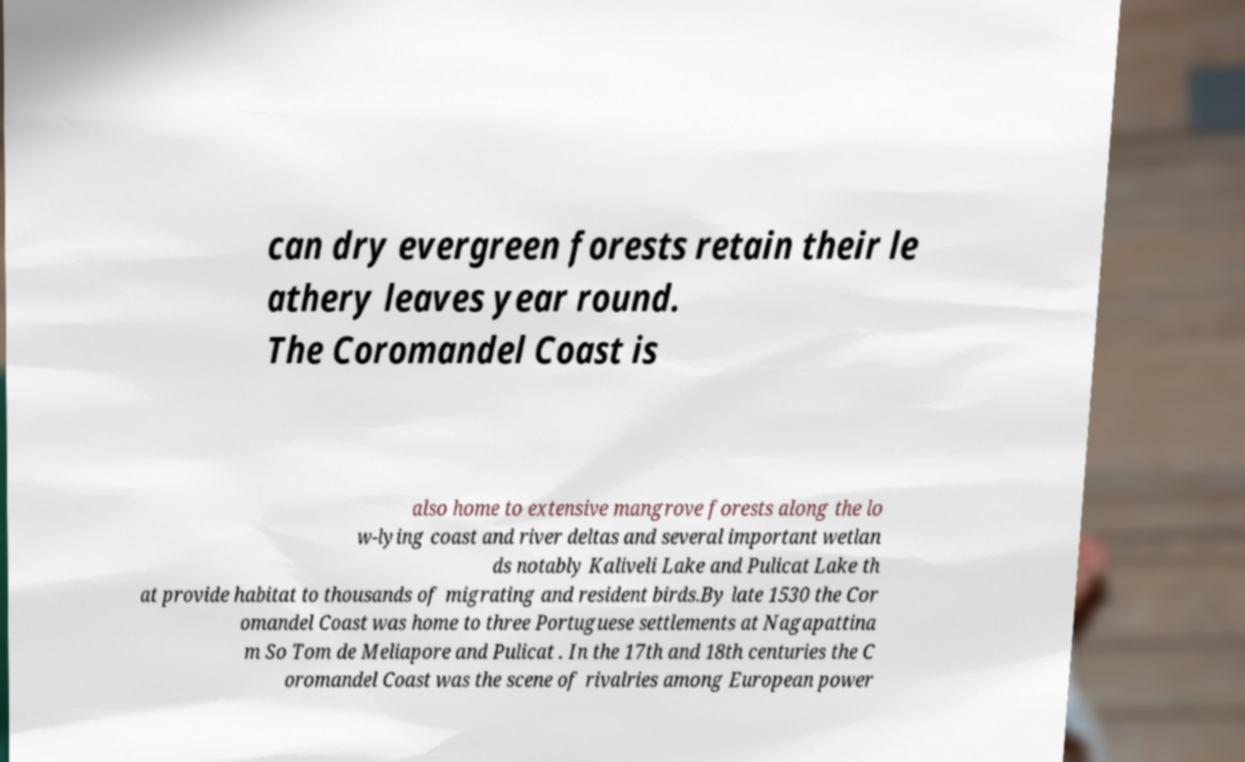Please read and relay the text visible in this image. What does it say? can dry evergreen forests retain their le athery leaves year round. The Coromandel Coast is also home to extensive mangrove forests along the lo w-lying coast and river deltas and several important wetlan ds notably Kaliveli Lake and Pulicat Lake th at provide habitat to thousands of migrating and resident birds.By late 1530 the Cor omandel Coast was home to three Portuguese settlements at Nagapattina m So Tom de Meliapore and Pulicat . In the 17th and 18th centuries the C oromandel Coast was the scene of rivalries among European power 